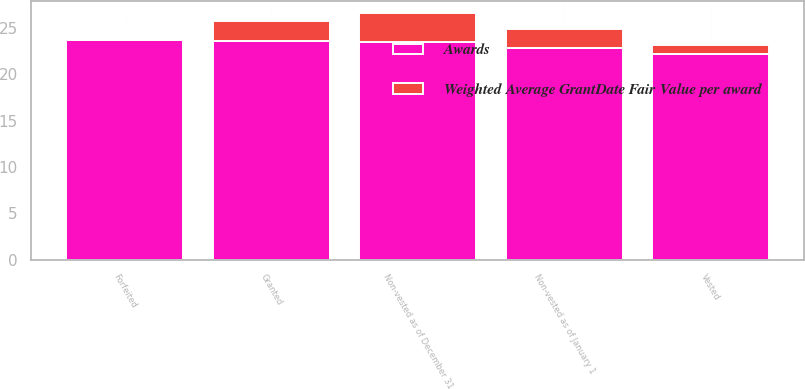Convert chart. <chart><loc_0><loc_0><loc_500><loc_500><stacked_bar_chart><ecel><fcel>Non-vested as of January 1<fcel>Granted<fcel>Vested<fcel>Forfeited<fcel>Non-vested as of December 31<nl><fcel>Weighted Average GrantDate Fair Value per award<fcel>2.1<fcel>2.1<fcel>1<fcel>0.1<fcel>3.1<nl><fcel>Awards<fcel>22.78<fcel>23.6<fcel>22.18<fcel>23.67<fcel>23.51<nl></chart> 